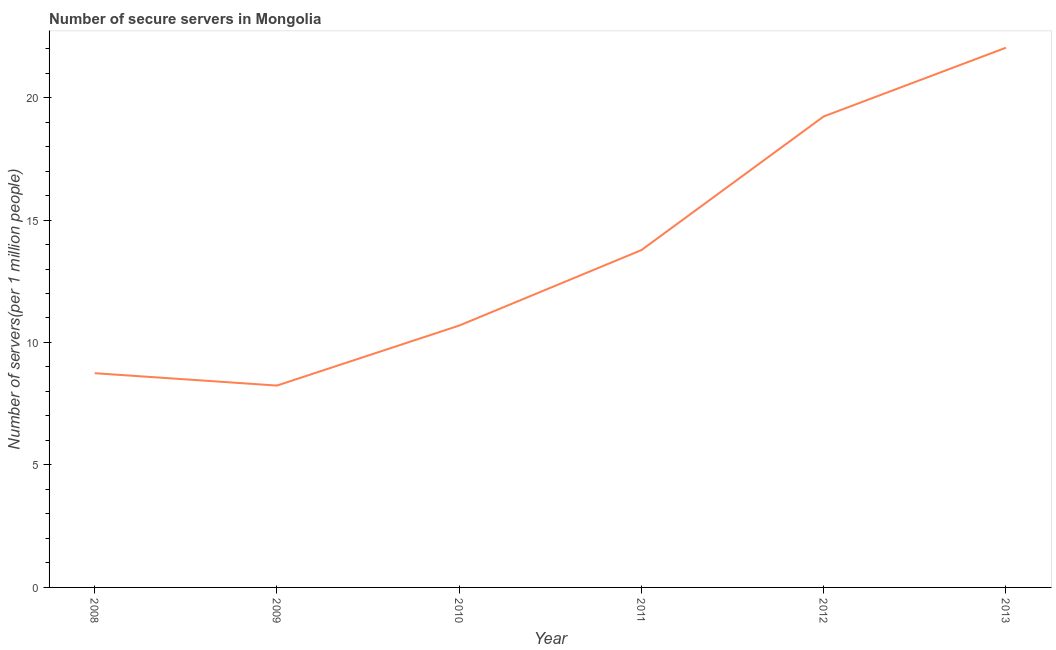What is the number of secure internet servers in 2008?
Provide a succinct answer. 8.75. Across all years, what is the maximum number of secure internet servers?
Your response must be concise. 22.03. Across all years, what is the minimum number of secure internet servers?
Offer a terse response. 8.24. What is the sum of the number of secure internet servers?
Ensure brevity in your answer.  82.71. What is the difference between the number of secure internet servers in 2010 and 2013?
Offer a very short reply. -11.34. What is the average number of secure internet servers per year?
Your answer should be very brief. 13.79. What is the median number of secure internet servers?
Your answer should be very brief. 12.23. In how many years, is the number of secure internet servers greater than 6 ?
Provide a short and direct response. 6. What is the ratio of the number of secure internet servers in 2011 to that in 2013?
Provide a succinct answer. 0.63. Is the difference between the number of secure internet servers in 2008 and 2013 greater than the difference between any two years?
Offer a very short reply. No. What is the difference between the highest and the second highest number of secure internet servers?
Provide a short and direct response. 2.81. What is the difference between the highest and the lowest number of secure internet servers?
Offer a very short reply. 13.79. Does the number of secure internet servers monotonically increase over the years?
Provide a short and direct response. No. How many lines are there?
Your answer should be very brief. 1. How many years are there in the graph?
Ensure brevity in your answer.  6. What is the difference between two consecutive major ticks on the Y-axis?
Ensure brevity in your answer.  5. What is the title of the graph?
Provide a succinct answer. Number of secure servers in Mongolia. What is the label or title of the Y-axis?
Offer a very short reply. Number of servers(per 1 million people). What is the Number of servers(per 1 million people) in 2008?
Your answer should be compact. 8.75. What is the Number of servers(per 1 million people) in 2009?
Offer a terse response. 8.24. What is the Number of servers(per 1 million people) of 2010?
Provide a short and direct response. 10.69. What is the Number of servers(per 1 million people) in 2011?
Ensure brevity in your answer.  13.77. What is the Number of servers(per 1 million people) of 2012?
Provide a short and direct response. 19.23. What is the Number of servers(per 1 million people) of 2013?
Offer a terse response. 22.03. What is the difference between the Number of servers(per 1 million people) in 2008 and 2009?
Ensure brevity in your answer.  0.51. What is the difference between the Number of servers(per 1 million people) in 2008 and 2010?
Give a very brief answer. -1.94. What is the difference between the Number of servers(per 1 million people) in 2008 and 2011?
Keep it short and to the point. -5.03. What is the difference between the Number of servers(per 1 million people) in 2008 and 2012?
Ensure brevity in your answer.  -10.48. What is the difference between the Number of servers(per 1 million people) in 2008 and 2013?
Ensure brevity in your answer.  -13.29. What is the difference between the Number of servers(per 1 million people) in 2009 and 2010?
Your answer should be compact. -2.45. What is the difference between the Number of servers(per 1 million people) in 2009 and 2011?
Provide a short and direct response. -5.53. What is the difference between the Number of servers(per 1 million people) in 2009 and 2012?
Provide a succinct answer. -10.99. What is the difference between the Number of servers(per 1 million people) in 2009 and 2013?
Your answer should be very brief. -13.79. What is the difference between the Number of servers(per 1 million people) in 2010 and 2011?
Offer a terse response. -3.08. What is the difference between the Number of servers(per 1 million people) in 2010 and 2012?
Offer a terse response. -8.54. What is the difference between the Number of servers(per 1 million people) in 2010 and 2013?
Provide a succinct answer. -11.34. What is the difference between the Number of servers(per 1 million people) in 2011 and 2012?
Ensure brevity in your answer.  -5.46. What is the difference between the Number of servers(per 1 million people) in 2011 and 2013?
Make the answer very short. -8.26. What is the difference between the Number of servers(per 1 million people) in 2012 and 2013?
Keep it short and to the point. -2.81. What is the ratio of the Number of servers(per 1 million people) in 2008 to that in 2009?
Keep it short and to the point. 1.06. What is the ratio of the Number of servers(per 1 million people) in 2008 to that in 2010?
Your answer should be compact. 0.82. What is the ratio of the Number of servers(per 1 million people) in 2008 to that in 2011?
Keep it short and to the point. 0.64. What is the ratio of the Number of servers(per 1 million people) in 2008 to that in 2012?
Keep it short and to the point. 0.46. What is the ratio of the Number of servers(per 1 million people) in 2008 to that in 2013?
Your answer should be very brief. 0.4. What is the ratio of the Number of servers(per 1 million people) in 2009 to that in 2010?
Provide a succinct answer. 0.77. What is the ratio of the Number of servers(per 1 million people) in 2009 to that in 2011?
Your answer should be compact. 0.6. What is the ratio of the Number of servers(per 1 million people) in 2009 to that in 2012?
Give a very brief answer. 0.43. What is the ratio of the Number of servers(per 1 million people) in 2009 to that in 2013?
Your answer should be very brief. 0.37. What is the ratio of the Number of servers(per 1 million people) in 2010 to that in 2011?
Offer a terse response. 0.78. What is the ratio of the Number of servers(per 1 million people) in 2010 to that in 2012?
Keep it short and to the point. 0.56. What is the ratio of the Number of servers(per 1 million people) in 2010 to that in 2013?
Your answer should be very brief. 0.48. What is the ratio of the Number of servers(per 1 million people) in 2011 to that in 2012?
Provide a short and direct response. 0.72. What is the ratio of the Number of servers(per 1 million people) in 2012 to that in 2013?
Make the answer very short. 0.87. 